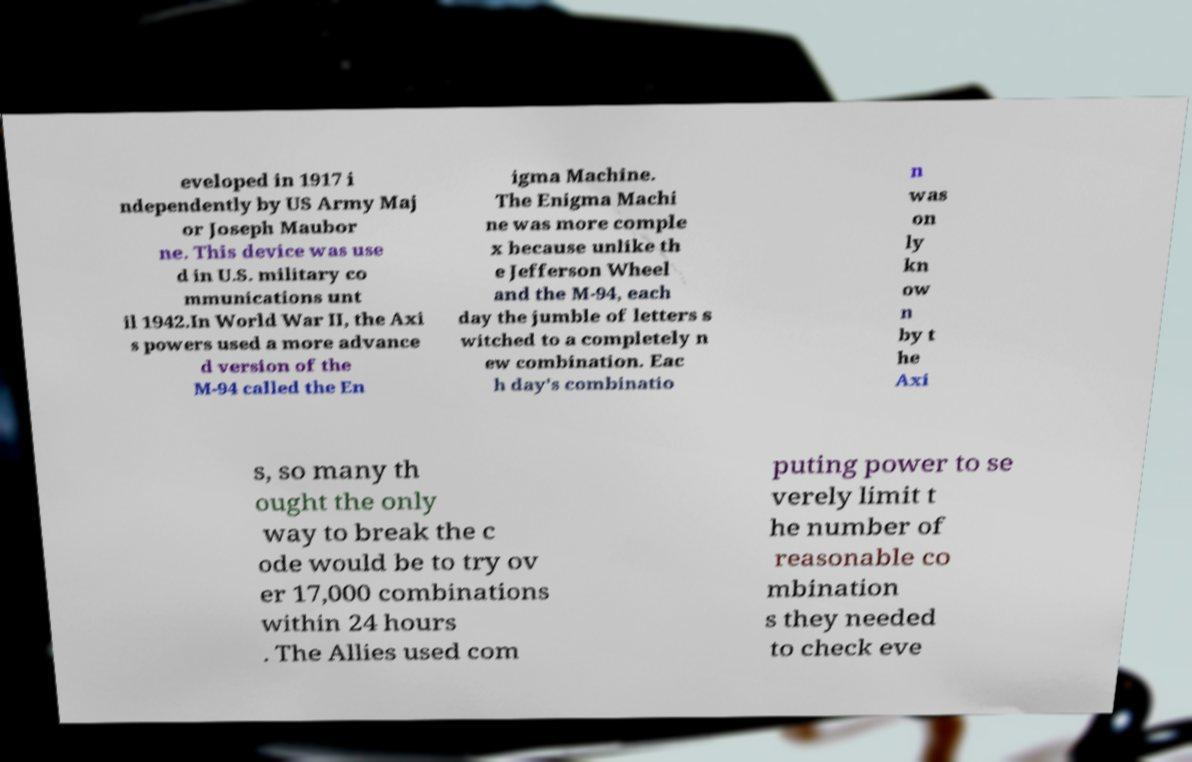I need the written content from this picture converted into text. Can you do that? eveloped in 1917 i ndependently by US Army Maj or Joseph Maubor ne. This device was use d in U.S. military co mmunications unt il 1942.In World War II, the Axi s powers used a more advance d version of the M-94 called the En igma Machine. The Enigma Machi ne was more comple x because unlike th e Jefferson Wheel and the M-94, each day the jumble of letters s witched to a completely n ew combination. Eac h day's combinatio n was on ly kn ow n by t he Axi s, so many th ought the only way to break the c ode would be to try ov er 17,000 combinations within 24 hours . The Allies used com puting power to se verely limit t he number of reasonable co mbination s they needed to check eve 